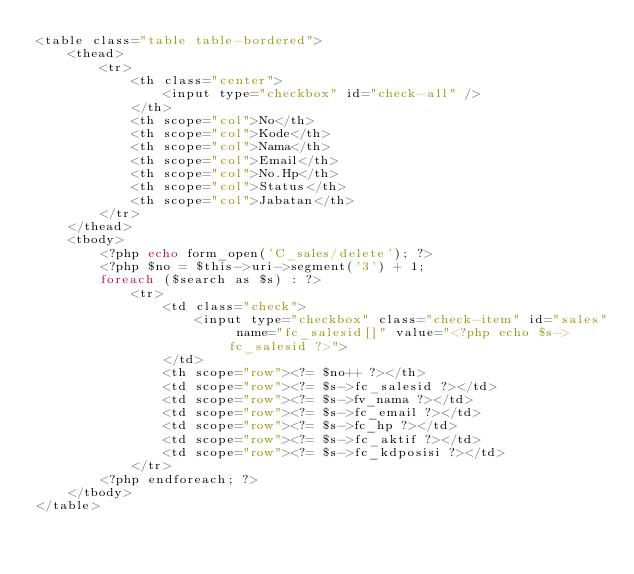Convert code to text. <code><loc_0><loc_0><loc_500><loc_500><_PHP_><table class="table table-bordered">
    <thead>
        <tr>
            <th class="center">
                <input type="checkbox" id="check-all" />
            </th>
            <th scope="col">No</th>
            <th scope="col">Kode</th>
            <th scope="col">Nama</th>
            <th scope="col">Email</th>
            <th scope="col">No.Hp</th>
            <th scope="col">Status</th>
            <th scope="col">Jabatan</th>
        </tr>
    </thead>
    <tbody>
        <?php echo form_open('C_sales/delete'); ?>
        <?php $no = $this->uri->segment('3') + 1;
        foreach ($search as $s) : ?>
            <tr>
                <td class="check">
                    <input type="checkbox" class="check-item" id="sales" name="fc_salesid[]" value="<?php echo $s->fc_salesid ?>">
                </td>
                <th scope="row"><?= $no++ ?></th>
                <td scope="row"><?= $s->fc_salesid ?></td>
                <td scope="row"><?= $s->fv_nama ?></td>
                <td scope="row"><?= $s->fc_email ?></td>
                <td scope="row"><?= $s->fc_hp ?></td>
                <td scope="row"><?= $s->fc_aktif ?></td>
                <td scope="row"><?= $s->fc_kdposisi ?></td>
            </tr>
        <?php endforeach; ?>
    </tbody>
</table></code> 